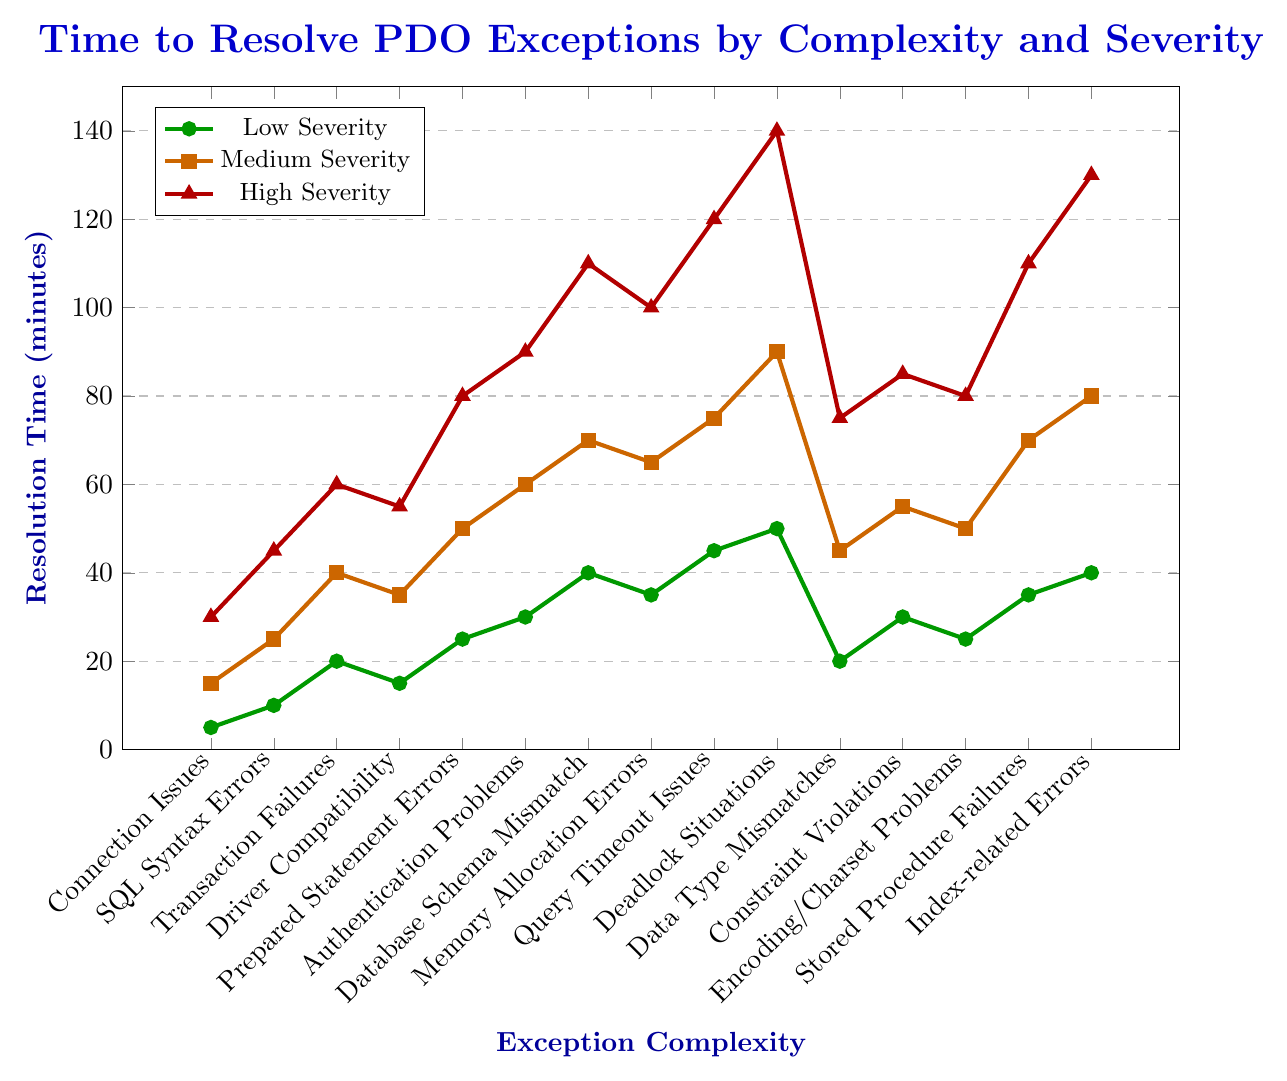Which complexity has the longest resolution time for high severity exceptions? Look for the highest point in the data series marked by red triangles, which represent high severity resolution times. The highest point is at the "Deadlock Situations" with a value of 140 minutes.
Answer: Deadlock Situations What is the difference in resolution time between low and high severity for "Prepared Statement Errors"? Identify the resolution times for "Prepared Statement Errors" for both low and high severity. These are 25 minutes (low) and 80 minutes (high). Calculate the difference: 80 - 25 = 55.
Answer: 55 minutes Which severity level shows the highest increase in resolution time from "Memory Allocation Errors" to "Query Timeout Issues"? For each severity level (low, medium, high), calculate the difference in resolution time between "Memory Allocation Errors" and "Query Timeout Issues." Low: 45 - 35 = 10, Medium: 75 - 65 = 10, High: 120 - 100 = 20. The highest increase is in the high severity level.
Answer: High severity What is the average resolution time for low severity exceptions? Add up all the resolution times for low severity and divide by the number of complexities. (5 + 10 + 20 + 15 + 25 + 30 + 40 + 35 + 45 + 50 + 20 + 30 + 25 + 35 + 40) / 15 = 28.67.
Answer: 28.67 minutes Which complexity has the smallest resolution time difference between medium and high severity levels? Calculate the resolution time differences for each complexity between medium and high severity levels. Connection Issues: 30 - 15 = 15, SQL Syntax Errors: 45 - 25 = 20, Transaction Failures: 60 - 40 = 20, ..., and so on. The smallest difference is for "Connection Issues" with 15 minutes.
Answer: Connection Issues For which complexity do all severity levels have resolution times within 50 minutes of each other? Check each complexity to see if the difference between the highest and the lowest resolution times across all severity levels is 50 minutes or less. "SQL Syntax Errors" has times of 10, 25, and 45 minutes; the maximum difference is 35 minutes.
Answer: SQL Syntax Errors 